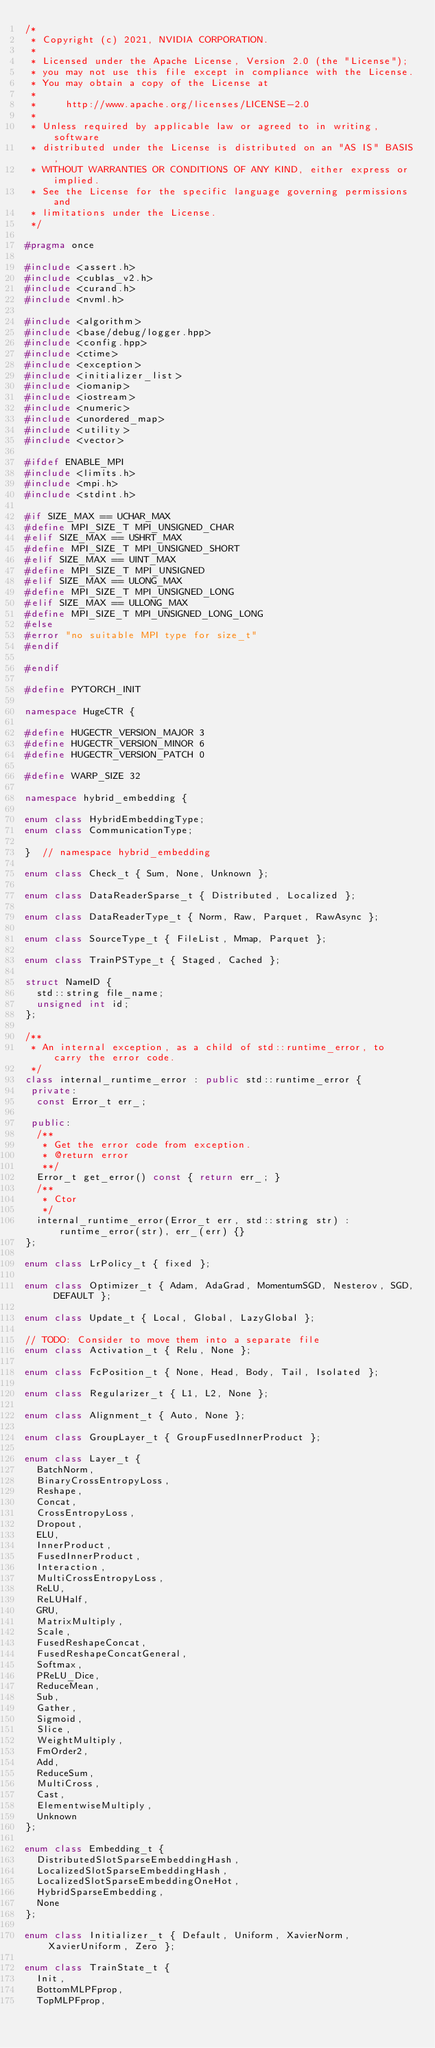<code> <loc_0><loc_0><loc_500><loc_500><_C++_>/*
 * Copyright (c) 2021, NVIDIA CORPORATION.
 *
 * Licensed under the Apache License, Version 2.0 (the "License");
 * you may not use this file except in compliance with the License.
 * You may obtain a copy of the License at
 *
 *     http://www.apache.org/licenses/LICENSE-2.0
 *
 * Unless required by applicable law or agreed to in writing, software
 * distributed under the License is distributed on an "AS IS" BASIS,
 * WITHOUT WARRANTIES OR CONDITIONS OF ANY KIND, either express or implied.
 * See the License for the specific language governing permissions and
 * limitations under the License.
 */

#pragma once

#include <assert.h>
#include <cublas_v2.h>
#include <curand.h>
#include <nvml.h>

#include <algorithm>
#include <base/debug/logger.hpp>
#include <config.hpp>
#include <ctime>
#include <exception>
#include <initializer_list>
#include <iomanip>
#include <iostream>
#include <numeric>
#include <unordered_map>
#include <utility>
#include <vector>

#ifdef ENABLE_MPI
#include <limits.h>
#include <mpi.h>
#include <stdint.h>

#if SIZE_MAX == UCHAR_MAX
#define MPI_SIZE_T MPI_UNSIGNED_CHAR
#elif SIZE_MAX == USHRT_MAX
#define MPI_SIZE_T MPI_UNSIGNED_SHORT
#elif SIZE_MAX == UINT_MAX
#define MPI_SIZE_T MPI_UNSIGNED
#elif SIZE_MAX == ULONG_MAX
#define MPI_SIZE_T MPI_UNSIGNED_LONG
#elif SIZE_MAX == ULLONG_MAX
#define MPI_SIZE_T MPI_UNSIGNED_LONG_LONG
#else
#error "no suitable MPI type for size_t"
#endif

#endif

#define PYTORCH_INIT

namespace HugeCTR {

#define HUGECTR_VERSION_MAJOR 3
#define HUGECTR_VERSION_MINOR 6
#define HUGECTR_VERSION_PATCH 0

#define WARP_SIZE 32

namespace hybrid_embedding {

enum class HybridEmbeddingType;
enum class CommunicationType;

}  // namespace hybrid_embedding

enum class Check_t { Sum, None, Unknown };

enum class DataReaderSparse_t { Distributed, Localized };

enum class DataReaderType_t { Norm, Raw, Parquet, RawAsync };

enum class SourceType_t { FileList, Mmap, Parquet };

enum class TrainPSType_t { Staged, Cached };

struct NameID {
  std::string file_name;
  unsigned int id;
};

/**
 * An internal exception, as a child of std::runtime_error, to carry the error code.
 */
class internal_runtime_error : public std::runtime_error {
 private:
  const Error_t err_;

 public:
  /**
   * Get the error code from exception.
   * @return error
   **/
  Error_t get_error() const { return err_; }
  /**
   * Ctor
   */
  internal_runtime_error(Error_t err, std::string str) : runtime_error(str), err_(err) {}
};

enum class LrPolicy_t { fixed };

enum class Optimizer_t { Adam, AdaGrad, MomentumSGD, Nesterov, SGD, DEFAULT };

enum class Update_t { Local, Global, LazyGlobal };

// TODO: Consider to move them into a separate file
enum class Activation_t { Relu, None };

enum class FcPosition_t { None, Head, Body, Tail, Isolated };

enum class Regularizer_t { L1, L2, None };

enum class Alignment_t { Auto, None };

enum class GroupLayer_t { GroupFusedInnerProduct };

enum class Layer_t {
  BatchNorm,
  BinaryCrossEntropyLoss,
  Reshape,
  Concat,
  CrossEntropyLoss,
  Dropout,
  ELU,
  InnerProduct,
  FusedInnerProduct,
  Interaction,
  MultiCrossEntropyLoss,
  ReLU,
  ReLUHalf,
  GRU,
  MatrixMultiply,
  Scale,
  FusedReshapeConcat,
  FusedReshapeConcatGeneral,
  Softmax,
  PReLU_Dice,
  ReduceMean,
  Sub,
  Gather,
  Sigmoid,
  Slice,
  WeightMultiply,
  FmOrder2,
  Add,
  ReduceSum,
  MultiCross,
  Cast,
  ElementwiseMultiply,
  Unknown
};

enum class Embedding_t {
  DistributedSlotSparseEmbeddingHash,
  LocalizedSlotSparseEmbeddingHash,
  LocalizedSlotSparseEmbeddingOneHot,
  HybridSparseEmbedding,
  None
};

enum class Initializer_t { Default, Uniform, XavierNorm, XavierUniform, Zero };

enum class TrainState_t {
  Init,
  BottomMLPFprop,
  TopMLPFprop,</code> 